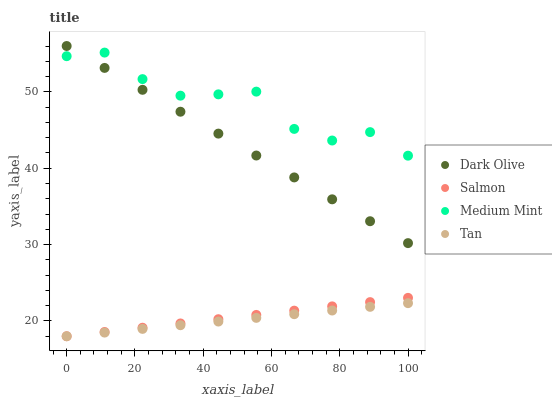Does Tan have the minimum area under the curve?
Answer yes or no. Yes. Does Medium Mint have the maximum area under the curve?
Answer yes or no. Yes. Does Dark Olive have the minimum area under the curve?
Answer yes or no. No. Does Dark Olive have the maximum area under the curve?
Answer yes or no. No. Is Salmon the smoothest?
Answer yes or no. Yes. Is Medium Mint the roughest?
Answer yes or no. Yes. Is Tan the smoothest?
Answer yes or no. No. Is Tan the roughest?
Answer yes or no. No. Does Tan have the lowest value?
Answer yes or no. Yes. Does Dark Olive have the lowest value?
Answer yes or no. No. Does Dark Olive have the highest value?
Answer yes or no. Yes. Does Tan have the highest value?
Answer yes or no. No. Is Salmon less than Dark Olive?
Answer yes or no. Yes. Is Medium Mint greater than Salmon?
Answer yes or no. Yes. Does Dark Olive intersect Medium Mint?
Answer yes or no. Yes. Is Dark Olive less than Medium Mint?
Answer yes or no. No. Is Dark Olive greater than Medium Mint?
Answer yes or no. No. Does Salmon intersect Dark Olive?
Answer yes or no. No. 